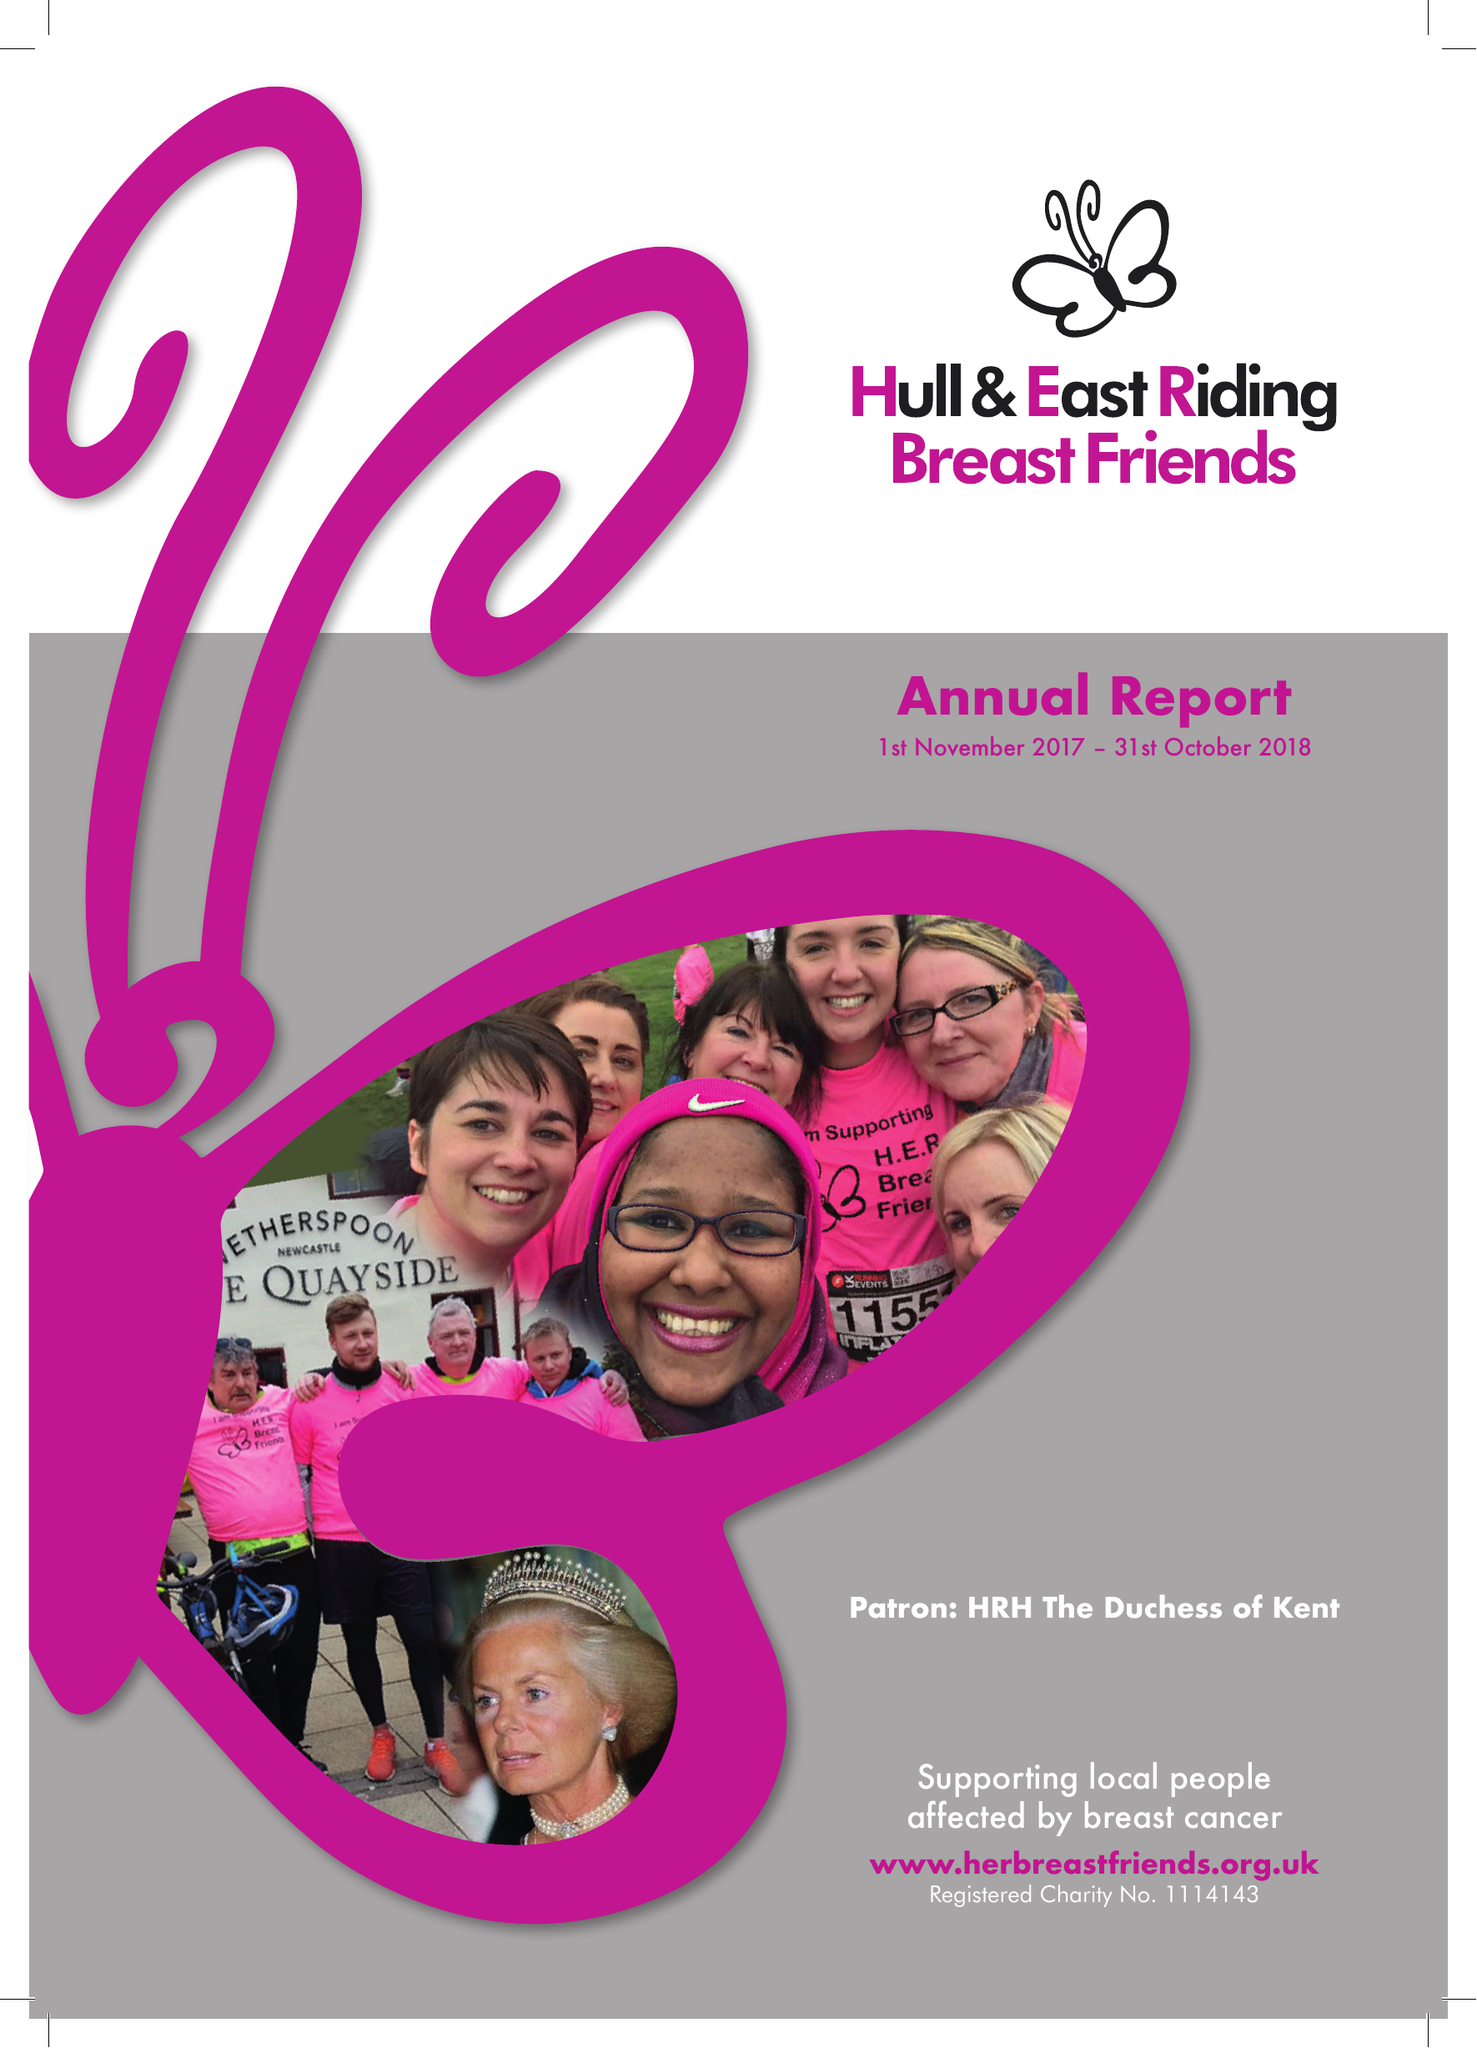What is the value for the income_annually_in_british_pounds?
Answer the question using a single word or phrase. 48862.00 